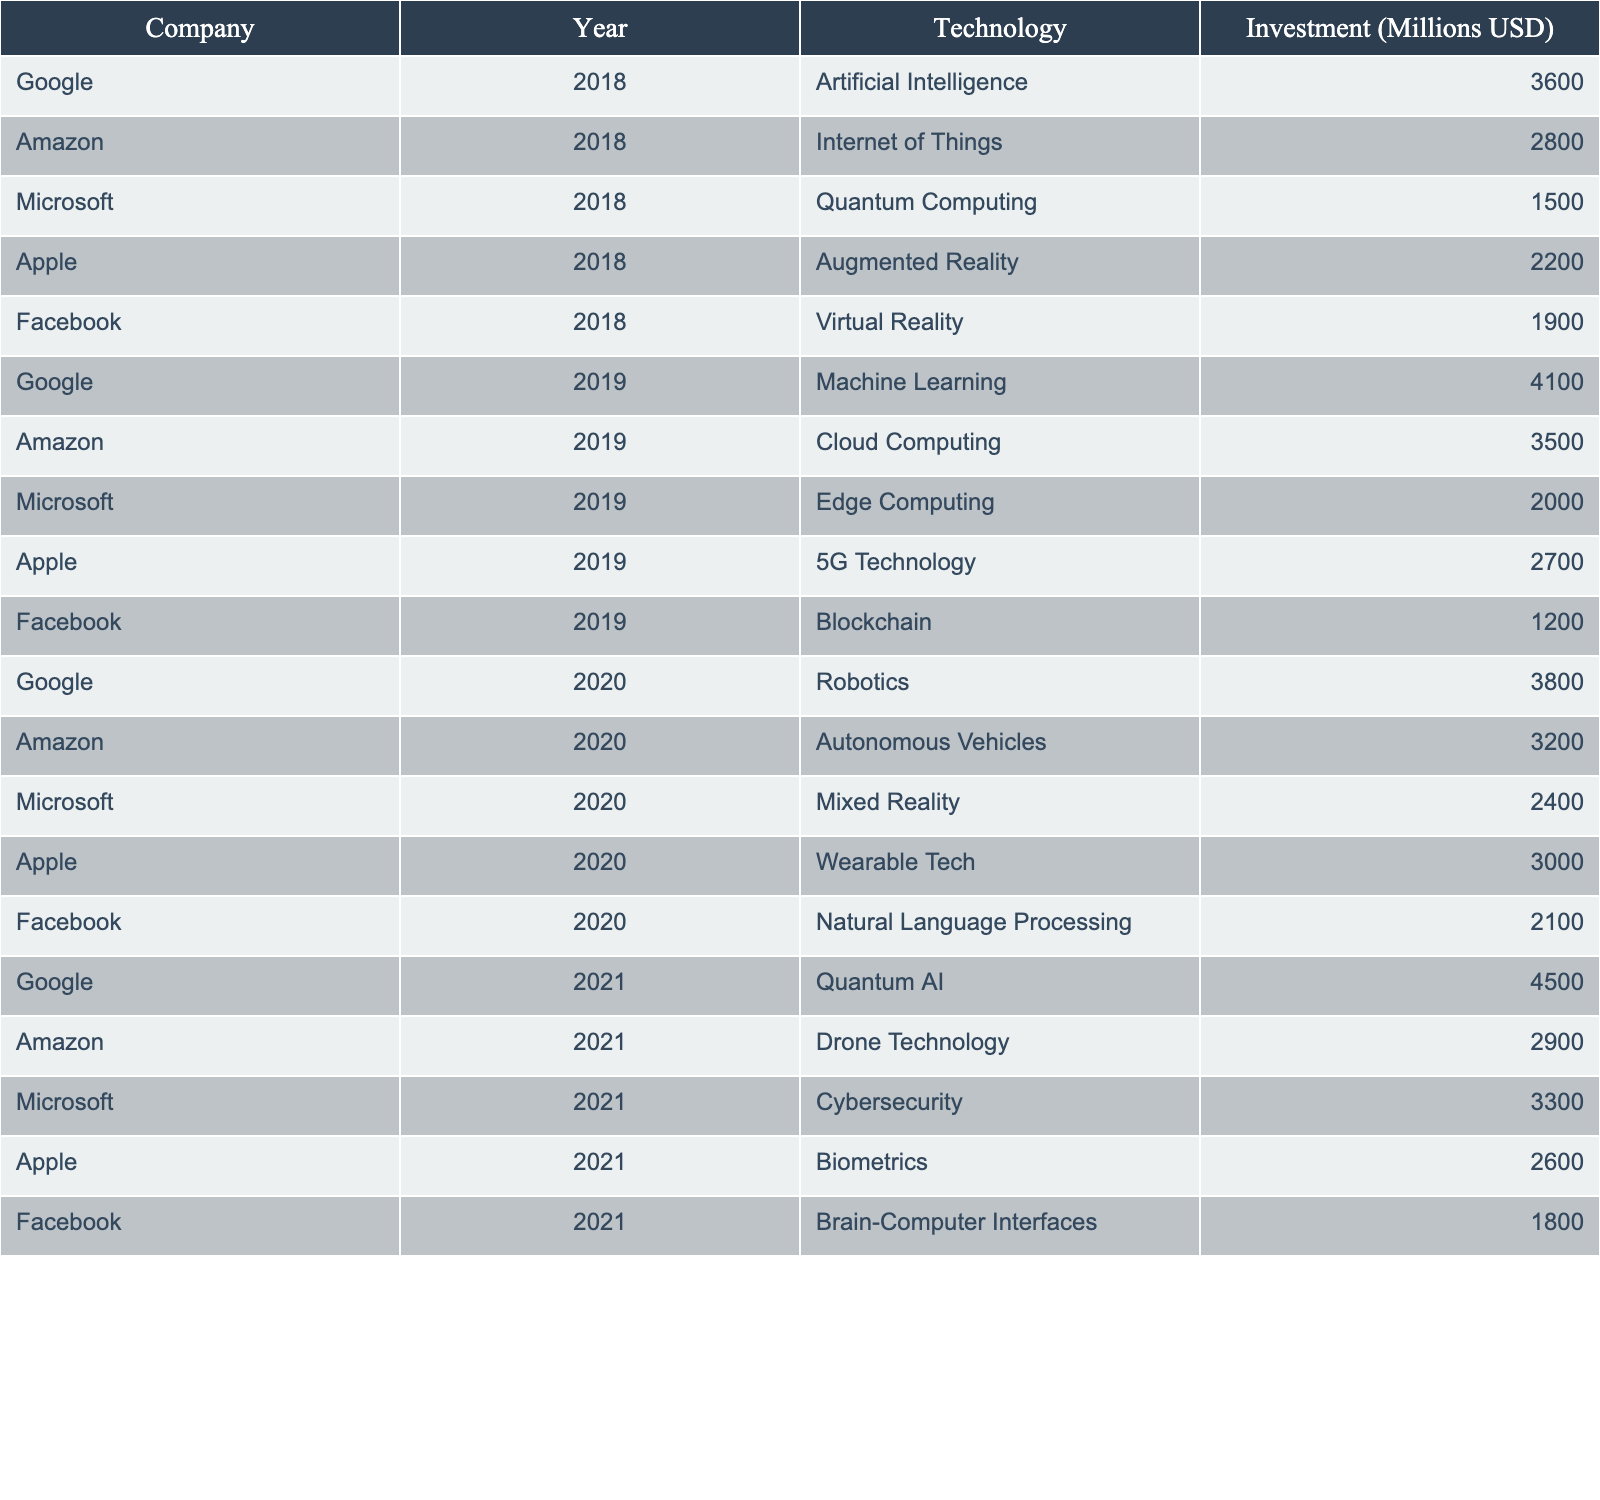What is the total investment in Artificial Intelligence from 2018 to 2021? We look for all entries related to Artificial Intelligence from 2018 to 2021. The amount for Google in 2018 is 3600. In 2021, Google's investment in Quantum AI is 4500. Therefore, the total investment is 3600 + 4500 = 8100 million USD.
Answer: 8100 million USD Which company invested the most in 2019? We review the investments for the year 2019, which are Google (4100), Amazon (3500), Microsoft (2000), Apple (2700), and Facebook (1200). The highest investment is from Google at 4100 million USD.
Answer: Google What was the average investment in Quantum Computing from 2018 to 2021? The investment in Quantum Computing is 1500 in 2018 and 4500 in 2021. There is no entry for 2019 and 2020. To find the average, we sum the investments: 1500 + 4500 = 6000, then divide by the number of entries (2): 6000 / 2 = 3000 million USD.
Answer: 3000 million USD Did Facebook ever invest more than 2000 million USD in any technology from 2018 to 2021? Looking at Facebook's investments: 1900 in 2018, 1200 in 2019, 2100 in 2020, and 1800 in 2021. The only value above 2000 is 2100 in 2020. Therefore, the answer is yes.
Answer: Yes What is the change in total investment for Amazon from 2018 to 2021? The investments are 2800 in 2018, 3500 in 2019, 3200 in 2020, and 2900 in 2021. Summing those gives 2800 + 3500 + 3200 + 2900 = 12400 million USD. The change from 2800 in 2018 to 2900 in 2021 is 2900 - 2800 = 100 million USD increase.
Answer: 100 million USD Which technology had the lowest total investment from 2018 to 2021? We sum investments for all technologies across the years. For example, Virtual Reality totaled 1900, Blockchain 1200, and so forth. Comparing totals, Blockchain has the lowest at 1200 million USD.
Answer: Blockchain Is there a year without any investment in Augmented Reality? The investments in Augmented Reality are recorded only for 2018 (2200). For 2019, 2020, and 2021, there are no entries for Augmented Reality. Therefore, the answer is yes, it is absent in those years.
Answer: Yes What was the highest investment made by Apple's technology in a single year? Reviewing Apple's investments, we have 2200 in 2018, 2700 in 2019, 3000 in 2020, and 2600 in 2021. The highest investment is 3000 million USD for Wearable Tech in 2020.
Answer: 3000 million USD Which company has made investments in both Artificial Intelligence and Cybersecurity? Reviewing investments, Google invested in Artificial Intelligence (3600 in 2018 and 4100 in 2019), and Microsoft invested in Cybersecurity (3300 in 2021). Both companies are involved, leading to the conclusion that the answer is both.
Answer: Both Google and Microsoft What was the overall trend in investment for Google across the years provided? Analyzing Google's yearly investments: 3600 in 2018, 4100 in 2019, 3800 in 2020, and 4500 in 2021, we can observe a general upward trend as the investments increased each year.
Answer: Upward trend 